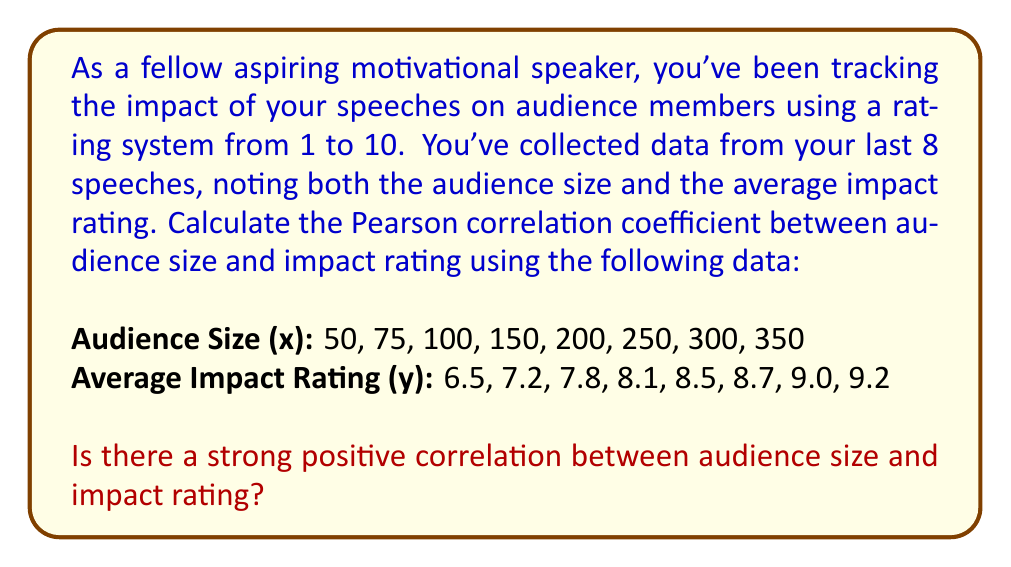Solve this math problem. To calculate the Pearson correlation coefficient (r) between audience size (x) and average impact rating (y), we'll use the formula:

$$ r = \frac{n\sum xy - \sum x \sum y}{\sqrt{[n\sum x^2 - (\sum x)^2][n\sum y^2 - (\sum y)^2]}} $$

Where n is the number of data points (8 in this case).

Step 1: Calculate the necessary sums:
$\sum x = 1475$
$\sum y = 65.0$
$\sum xy = 12,725$
$\sum x^2 = 418,125$
$\sum y^2 = 531.74$

Step 2: Substitute these values into the formula:

$$ r = \frac{8(12,725) - (1475)(65.0)}{\sqrt{[8(418,125) - (1475)^2][8(531.74) - (65.0)^2]}} $$

Step 3: Simplify:

$$ r = \frac{101,800 - 95,875}{\sqrt{(3,345,000 - 2,175,625)(4,253.92 - 4,225)}} $$

$$ r = \frac{5,925}{\sqrt{(1,169,375)(28.92)}} $$

$$ r = \frac{5,925}{\sqrt{33,818,325}} $$

$$ r = \frac{5,925}{5,816.22} $$

$$ r \approx 0.9843 $$

Step 4: Interpret the result:
The Pearson correlation coefficient ranges from -1 to 1, where:
- 1 indicates a perfect positive correlation
- 0 indicates no correlation
- -1 indicates a perfect negative correlation

A value of 0.9843 is very close to 1, indicating a strong positive correlation between audience size and impact rating.
Answer: The Pearson correlation coefficient is approximately 0.9843, indicating a strong positive correlation between audience size and impact rating. 